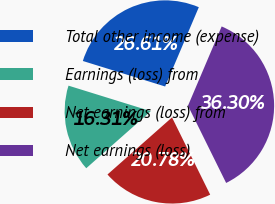Convert chart. <chart><loc_0><loc_0><loc_500><loc_500><pie_chart><fcel>Total other income (expense)<fcel>Earnings (loss) from<fcel>Net earnings (loss) from<fcel>Net earnings (loss)<nl><fcel>26.61%<fcel>16.31%<fcel>20.78%<fcel>36.3%<nl></chart> 